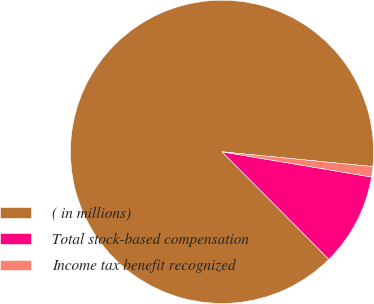<chart> <loc_0><loc_0><loc_500><loc_500><pie_chart><fcel>( in millions)<fcel>Total stock-based compensation<fcel>Income tax benefit recognized<nl><fcel>89.0%<fcel>9.89%<fcel>1.1%<nl></chart> 